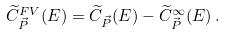Convert formula to latex. <formula><loc_0><loc_0><loc_500><loc_500>\widetilde { C } _ { \vec { P } } ^ { F V } ( E ) = \widetilde { C } _ { \vec { P } } ( E ) - \widetilde { C } _ { \vec { P } } ^ { \infty } ( E ) \, .</formula> 